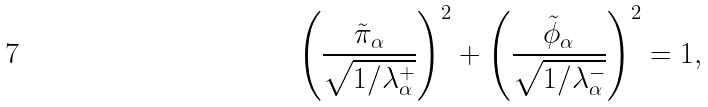Convert formula to latex. <formula><loc_0><loc_0><loc_500><loc_500>\left ( \frac { \tilde { \pi } _ { \alpha } } { \sqrt { 1 / \lambda ^ { + } _ { \alpha } } } \right ) ^ { 2 } + \left ( \frac { \tilde { \phi } _ { \alpha } } { \sqrt { 1 / \lambda ^ { - } _ { \alpha } } } \right ) ^ { 2 } = 1 ,</formula> 